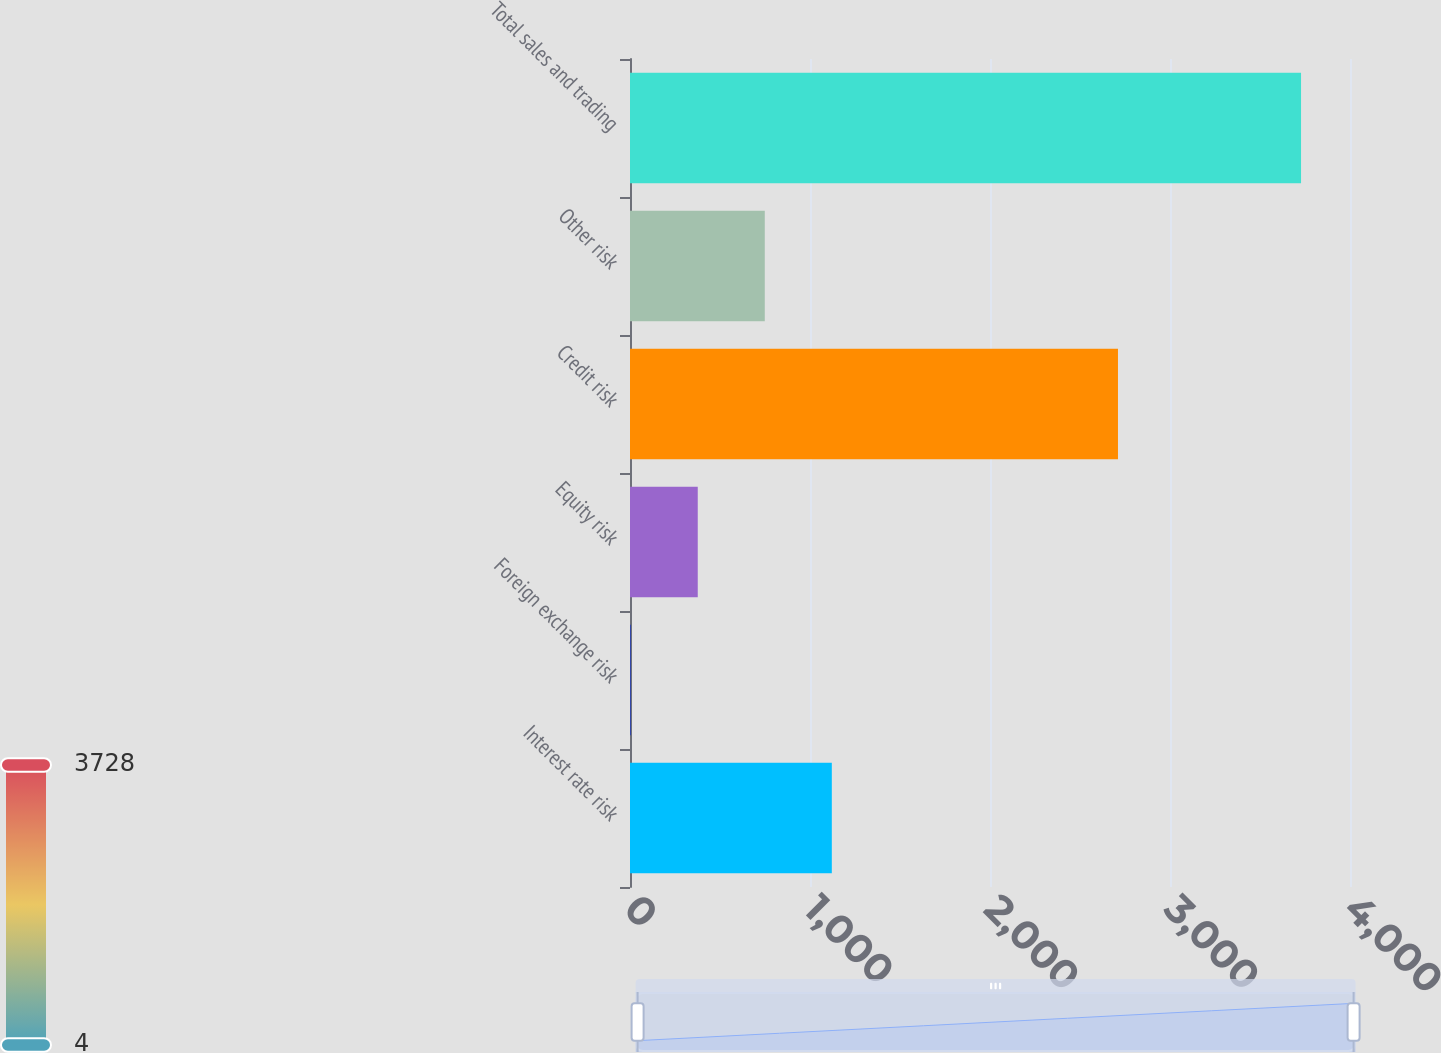Convert chart. <chart><loc_0><loc_0><loc_500><loc_500><bar_chart><fcel>Interest rate risk<fcel>Foreign exchange risk<fcel>Equity risk<fcel>Credit risk<fcel>Other risk<fcel>Total sales and trading<nl><fcel>1121.2<fcel>4<fcel>376.4<fcel>2711<fcel>748.8<fcel>3728<nl></chart> 